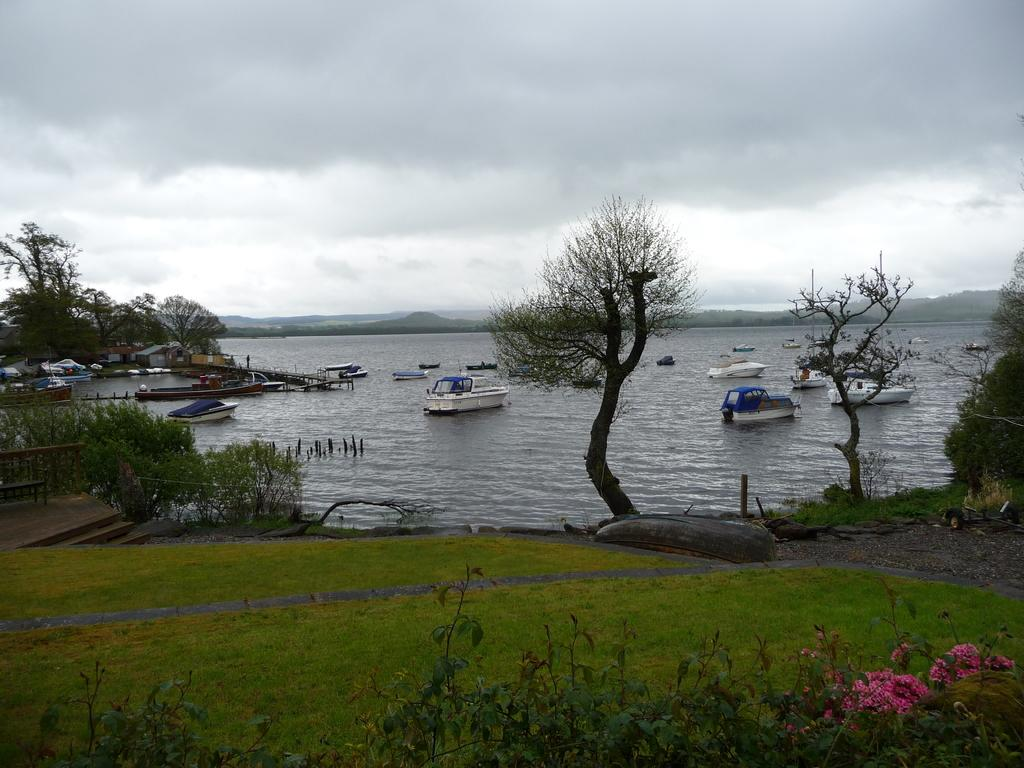What is on the water in the image? There are boats on the water in the image. What type of structures can be seen in the image? There are houses in the image. What type of vegetation is present in the image? There are trees in the image. What can be seen in the sky in the image? There are clouds in the image. Where are the flowers located in the image? The flowers are at the right bottom of the image. How many boys are playing with the fairies in the image? There are no boys or fairies present in the image. What is the tax rate for the houses in the image? There is no information about tax rates in the image. 